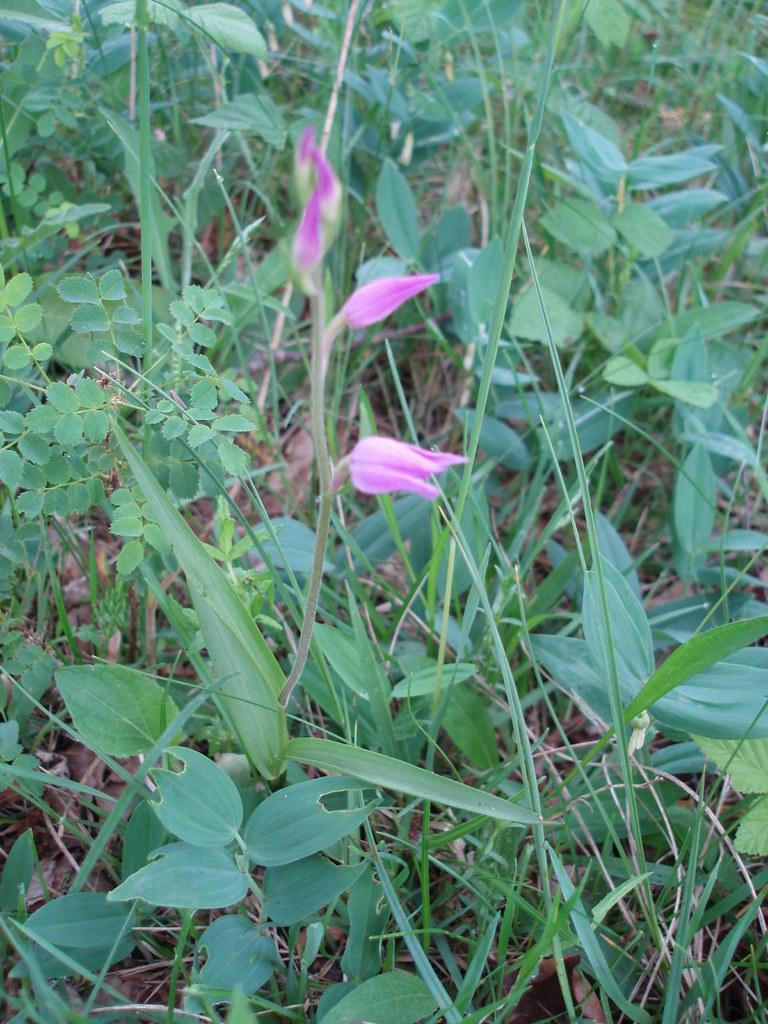How many flowers are on the plant in the foreground of the image? There are three flowers on a plant in the foreground of the image. What type of vegetation is visible in the image? Grass is visible in the image. Are there any other plants besides the one with flowers in the image? Yes, there are other plants in the image. What type of chin can be seen on the plant in the image? There is no chin present on the plant in the image, as plants do not have chins. 